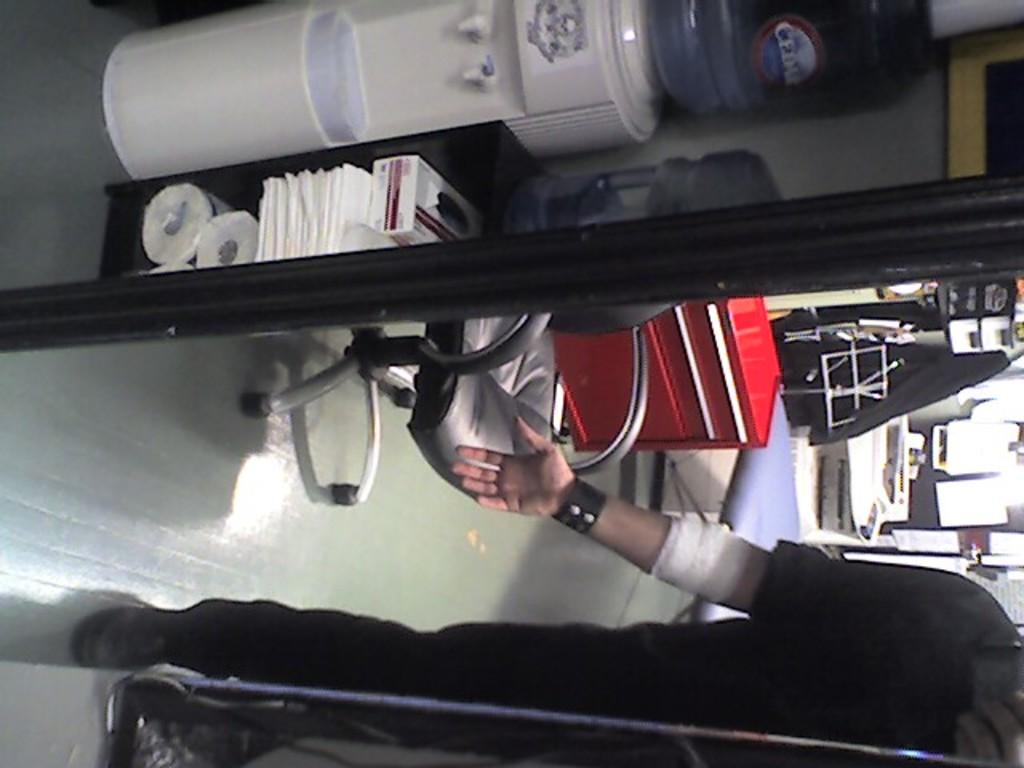What is the person in the image doing? The person is on the floor in the image. What device is present in the image for purifying water? There is a water purifier in the image. What containers are visible for storing water? Water cans are visible in the image. What type of furniture is present in the image? There is a chair in the image. What type of decorations are present in the image? Posters are present in the image. What type of material is visible in the image? Cloth is visible in the image. What other unspecified objects are present in the image? There are some unspecified objects in the image. How many muscles can be seen in the person's eye in the image? There are no muscles or eyes visible in the image; it only shows a person on the floor, a water purifier, water cans, a chair, posters, cloth, and unspecified objects. 